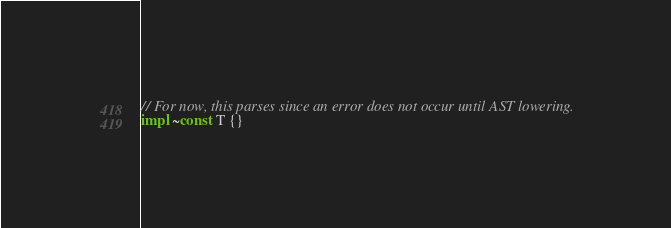Convert code to text. <code><loc_0><loc_0><loc_500><loc_500><_Rust_>
// For now, this parses since an error does not occur until AST lowering.
impl ~const T {}
</code> 